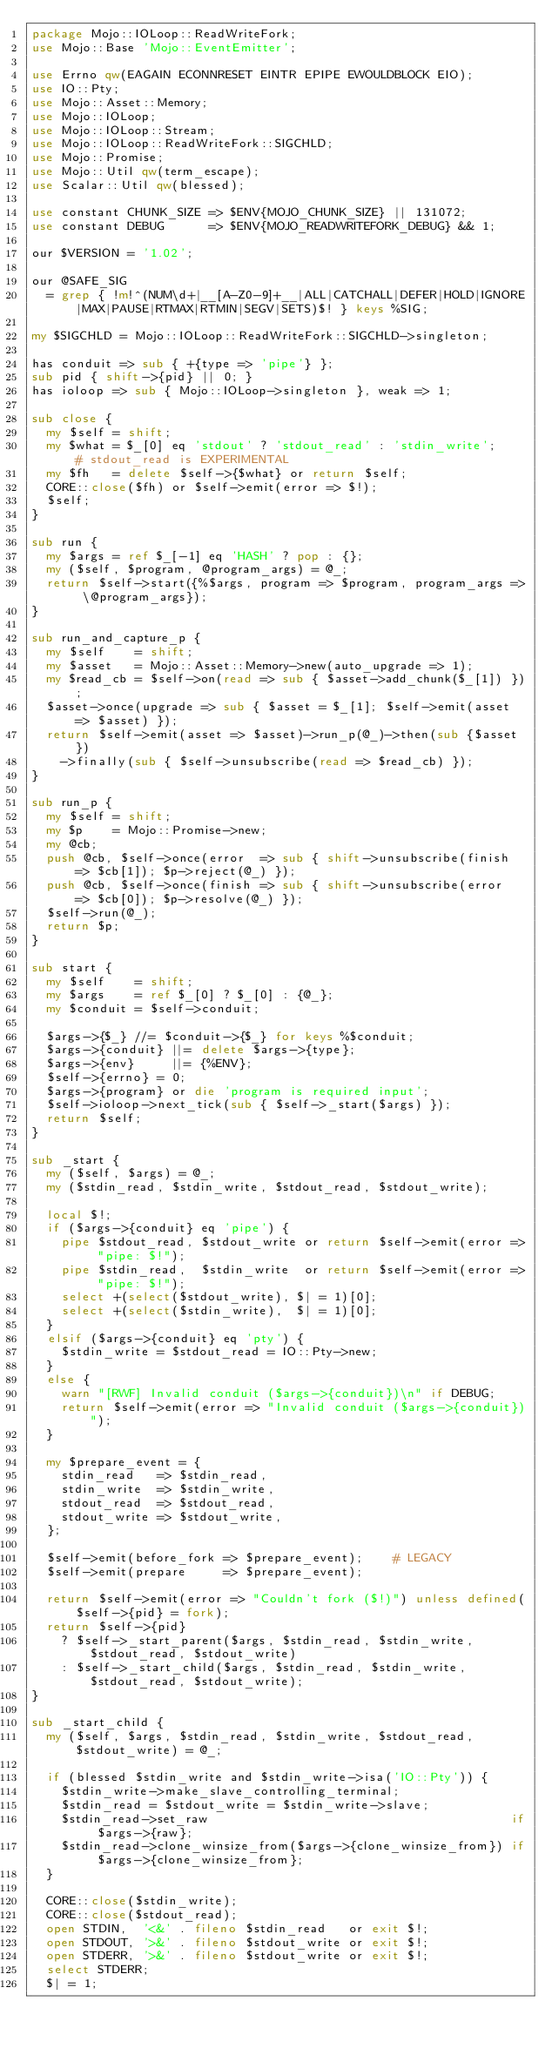Convert code to text. <code><loc_0><loc_0><loc_500><loc_500><_Perl_>package Mojo::IOLoop::ReadWriteFork;
use Mojo::Base 'Mojo::EventEmitter';

use Errno qw(EAGAIN ECONNRESET EINTR EPIPE EWOULDBLOCK EIO);
use IO::Pty;
use Mojo::Asset::Memory;
use Mojo::IOLoop;
use Mojo::IOLoop::Stream;
use Mojo::IOLoop::ReadWriteFork::SIGCHLD;
use Mojo::Promise;
use Mojo::Util qw(term_escape);
use Scalar::Util qw(blessed);

use constant CHUNK_SIZE => $ENV{MOJO_CHUNK_SIZE} || 131072;
use constant DEBUG      => $ENV{MOJO_READWRITEFORK_DEBUG} && 1;

our $VERSION = '1.02';

our @SAFE_SIG
  = grep { !m!^(NUM\d+|__[A-Z0-9]+__|ALL|CATCHALL|DEFER|HOLD|IGNORE|MAX|PAUSE|RTMAX|RTMIN|SEGV|SETS)$! } keys %SIG;

my $SIGCHLD = Mojo::IOLoop::ReadWriteFork::SIGCHLD->singleton;

has conduit => sub { +{type => 'pipe'} };
sub pid { shift->{pid} || 0; }
has ioloop => sub { Mojo::IOLoop->singleton }, weak => 1;

sub close {
  my $self = shift;
  my $what = $_[0] eq 'stdout' ? 'stdout_read' : 'stdin_write';    # stdout_read is EXPERIMENTAL
  my $fh   = delete $self->{$what} or return $self;
  CORE::close($fh) or $self->emit(error => $!);
  $self;
}

sub run {
  my $args = ref $_[-1] eq 'HASH' ? pop : {};
  my ($self, $program, @program_args) = @_;
  return $self->start({%$args, program => $program, program_args => \@program_args});
}

sub run_and_capture_p {
  my $self    = shift;
  my $asset   = Mojo::Asset::Memory->new(auto_upgrade => 1);
  my $read_cb = $self->on(read => sub { $asset->add_chunk($_[1]) });
  $asset->once(upgrade => sub { $asset = $_[1]; $self->emit(asset => $asset) });
  return $self->emit(asset => $asset)->run_p(@_)->then(sub {$asset})
    ->finally(sub { $self->unsubscribe(read => $read_cb) });
}

sub run_p {
  my $self = shift;
  my $p    = Mojo::Promise->new;
  my @cb;
  push @cb, $self->once(error  => sub { shift->unsubscribe(finish => $cb[1]); $p->reject(@_) });
  push @cb, $self->once(finish => sub { shift->unsubscribe(error  => $cb[0]); $p->resolve(@_) });
  $self->run(@_);
  return $p;
}

sub start {
  my $self    = shift;
  my $args    = ref $_[0] ? $_[0] : {@_};
  my $conduit = $self->conduit;

  $args->{$_} //= $conduit->{$_} for keys %$conduit;
  $args->{conduit} ||= delete $args->{type};
  $args->{env}     ||= {%ENV};
  $self->{errno} = 0;
  $args->{program} or die 'program is required input';
  $self->ioloop->next_tick(sub { $self->_start($args) });
  return $self;
}

sub _start {
  my ($self, $args) = @_;
  my ($stdin_read, $stdin_write, $stdout_read, $stdout_write);

  local $!;
  if ($args->{conduit} eq 'pipe') {
    pipe $stdout_read, $stdout_write or return $self->emit(error => "pipe: $!");
    pipe $stdin_read,  $stdin_write  or return $self->emit(error => "pipe: $!");
    select +(select($stdout_write), $| = 1)[0];
    select +(select($stdin_write),  $| = 1)[0];
  }
  elsif ($args->{conduit} eq 'pty') {
    $stdin_write = $stdout_read = IO::Pty->new;
  }
  else {
    warn "[RWF] Invalid conduit ($args->{conduit})\n" if DEBUG;
    return $self->emit(error => "Invalid conduit ($args->{conduit})");
  }

  my $prepare_event = {
    stdin_read   => $stdin_read,
    stdin_write  => $stdin_write,
    stdout_read  => $stdout_read,
    stdout_write => $stdout_write,
  };

  $self->emit(before_fork => $prepare_event);    # LEGACY
  $self->emit(prepare     => $prepare_event);

  return $self->emit(error => "Couldn't fork ($!)") unless defined($self->{pid} = fork);
  return $self->{pid}
    ? $self->_start_parent($args, $stdin_read, $stdin_write, $stdout_read, $stdout_write)
    : $self->_start_child($args, $stdin_read, $stdin_write, $stdout_read, $stdout_write);
}

sub _start_child {
  my ($self, $args, $stdin_read, $stdin_write, $stdout_read, $stdout_write) = @_;

  if (blessed $stdin_write and $stdin_write->isa('IO::Pty')) {
    $stdin_write->make_slave_controlling_terminal;
    $stdin_read = $stdout_write = $stdin_write->slave;
    $stdin_read->set_raw                                         if $args->{raw};
    $stdin_read->clone_winsize_from($args->{clone_winsize_from}) if $args->{clone_winsize_from};
  }

  CORE::close($stdin_write);
  CORE::close($stdout_read);
  open STDIN,  '<&' . fileno $stdin_read   or exit $!;
  open STDOUT, '>&' . fileno $stdout_write or exit $!;
  open STDERR, '>&' . fileno $stdout_write or exit $!;
  select STDERR;
  $| = 1;</code> 